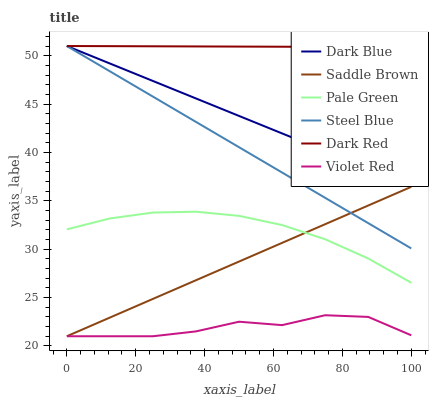Does Violet Red have the minimum area under the curve?
Answer yes or no. Yes. Does Dark Red have the maximum area under the curve?
Answer yes or no. Yes. Does Steel Blue have the minimum area under the curve?
Answer yes or no. No. Does Steel Blue have the maximum area under the curve?
Answer yes or no. No. Is Steel Blue the smoothest?
Answer yes or no. Yes. Is Violet Red the roughest?
Answer yes or no. Yes. Is Dark Red the smoothest?
Answer yes or no. No. Is Dark Red the roughest?
Answer yes or no. No. Does Violet Red have the lowest value?
Answer yes or no. Yes. Does Steel Blue have the lowest value?
Answer yes or no. No. Does Dark Blue have the highest value?
Answer yes or no. Yes. Does Pale Green have the highest value?
Answer yes or no. No. Is Violet Red less than Dark Red?
Answer yes or no. Yes. Is Pale Green greater than Violet Red?
Answer yes or no. Yes. Does Dark Red intersect Dark Blue?
Answer yes or no. Yes. Is Dark Red less than Dark Blue?
Answer yes or no. No. Is Dark Red greater than Dark Blue?
Answer yes or no. No. Does Violet Red intersect Dark Red?
Answer yes or no. No. 